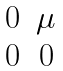Convert formula to latex. <formula><loc_0><loc_0><loc_500><loc_500>\begin{matrix} 0 & \mu \\ 0 & 0 \\ \end{matrix}</formula> 